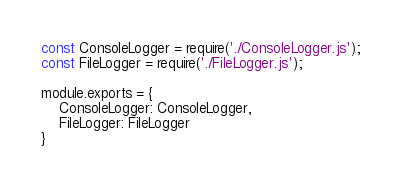Convert code to text. <code><loc_0><loc_0><loc_500><loc_500><_JavaScript_>const ConsoleLogger = require('./ConsoleLogger.js');
const FileLogger = require('./FileLogger.js');

module.exports = {
    ConsoleLogger: ConsoleLogger,
    FileLogger: FileLogger
}</code> 